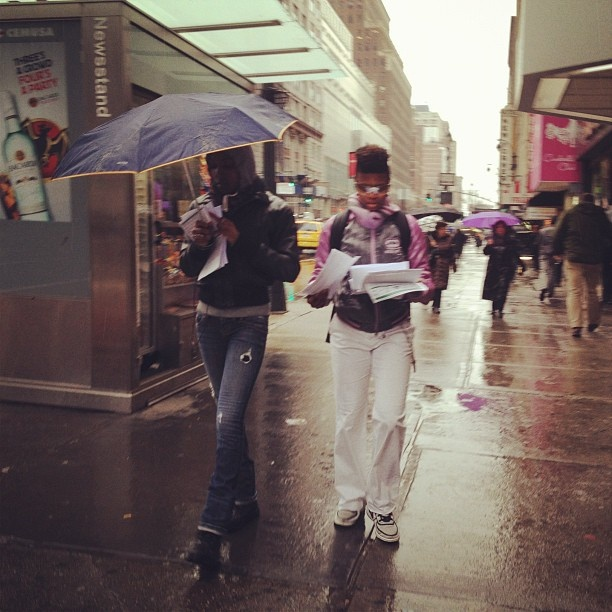Describe the objects in this image and their specific colors. I can see people in beige, black, and gray tones, people in beige, darkgray, black, and gray tones, umbrella in beige and gray tones, people in beige, black, gray, and tan tones, and people in beige, black, maroon, gray, and darkgray tones in this image. 